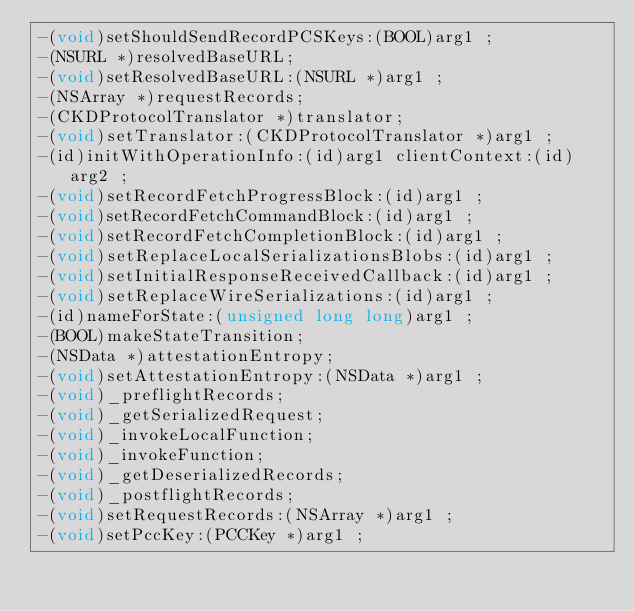Convert code to text. <code><loc_0><loc_0><loc_500><loc_500><_C_>-(void)setShouldSendRecordPCSKeys:(BOOL)arg1 ;
-(NSURL *)resolvedBaseURL;
-(void)setResolvedBaseURL:(NSURL *)arg1 ;
-(NSArray *)requestRecords;
-(CKDProtocolTranslator *)translator;
-(void)setTranslator:(CKDProtocolTranslator *)arg1 ;
-(id)initWithOperationInfo:(id)arg1 clientContext:(id)arg2 ;
-(void)setRecordFetchProgressBlock:(id)arg1 ;
-(void)setRecordFetchCommandBlock:(id)arg1 ;
-(void)setRecordFetchCompletionBlock:(id)arg1 ;
-(void)setReplaceLocalSerializationsBlobs:(id)arg1 ;
-(void)setInitialResponseReceivedCallback:(id)arg1 ;
-(void)setReplaceWireSerializations:(id)arg1 ;
-(id)nameForState:(unsigned long long)arg1 ;
-(BOOL)makeStateTransition;
-(NSData *)attestationEntropy;
-(void)setAttestationEntropy:(NSData *)arg1 ;
-(void)_preflightRecords;
-(void)_getSerializedRequest;
-(void)_invokeLocalFunction;
-(void)_invokeFunction;
-(void)_getDeserializedRecords;
-(void)_postflightRecords;
-(void)setRequestRecords:(NSArray *)arg1 ;
-(void)setPccKey:(PCCKey *)arg1 ;</code> 